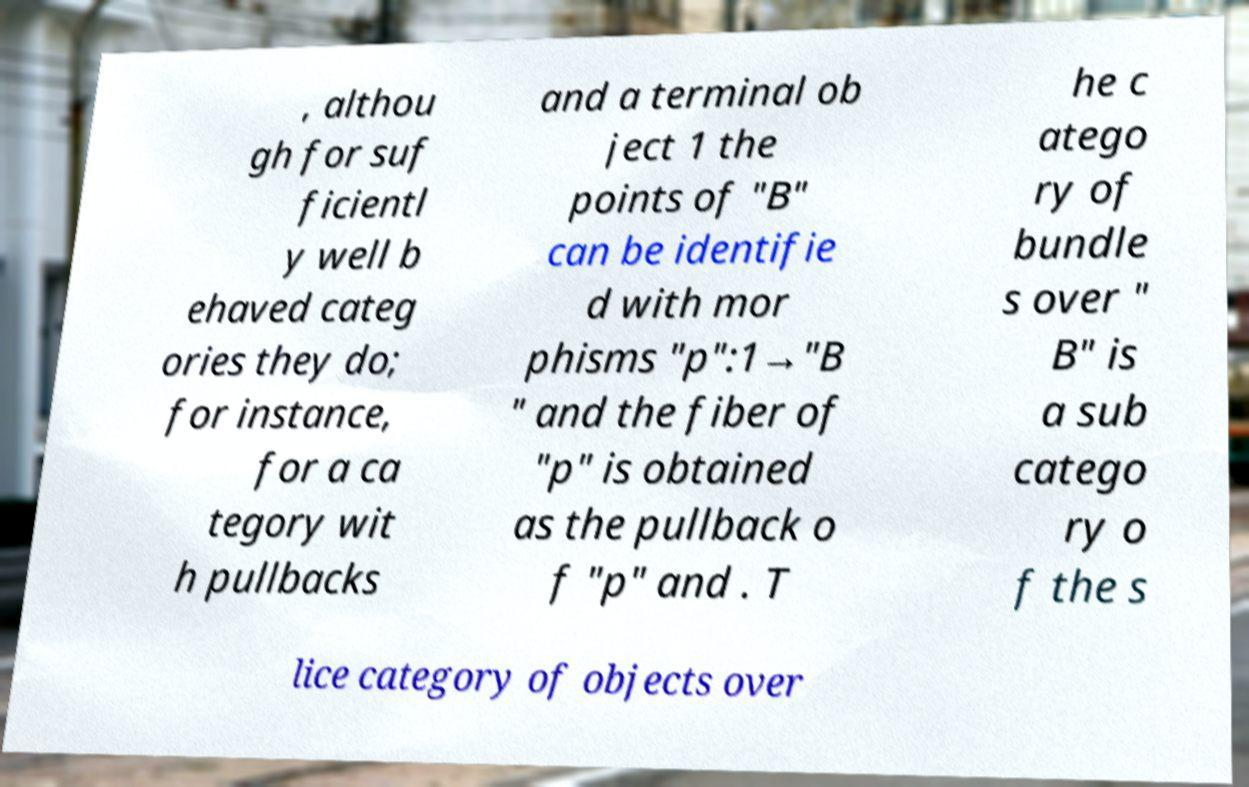Can you read and provide the text displayed in the image?This photo seems to have some interesting text. Can you extract and type it out for me? , althou gh for suf ficientl y well b ehaved categ ories they do; for instance, for a ca tegory wit h pullbacks and a terminal ob ject 1 the points of "B" can be identifie d with mor phisms "p":1→"B " and the fiber of "p" is obtained as the pullback o f "p" and . T he c atego ry of bundle s over " B" is a sub catego ry o f the s lice category of objects over 